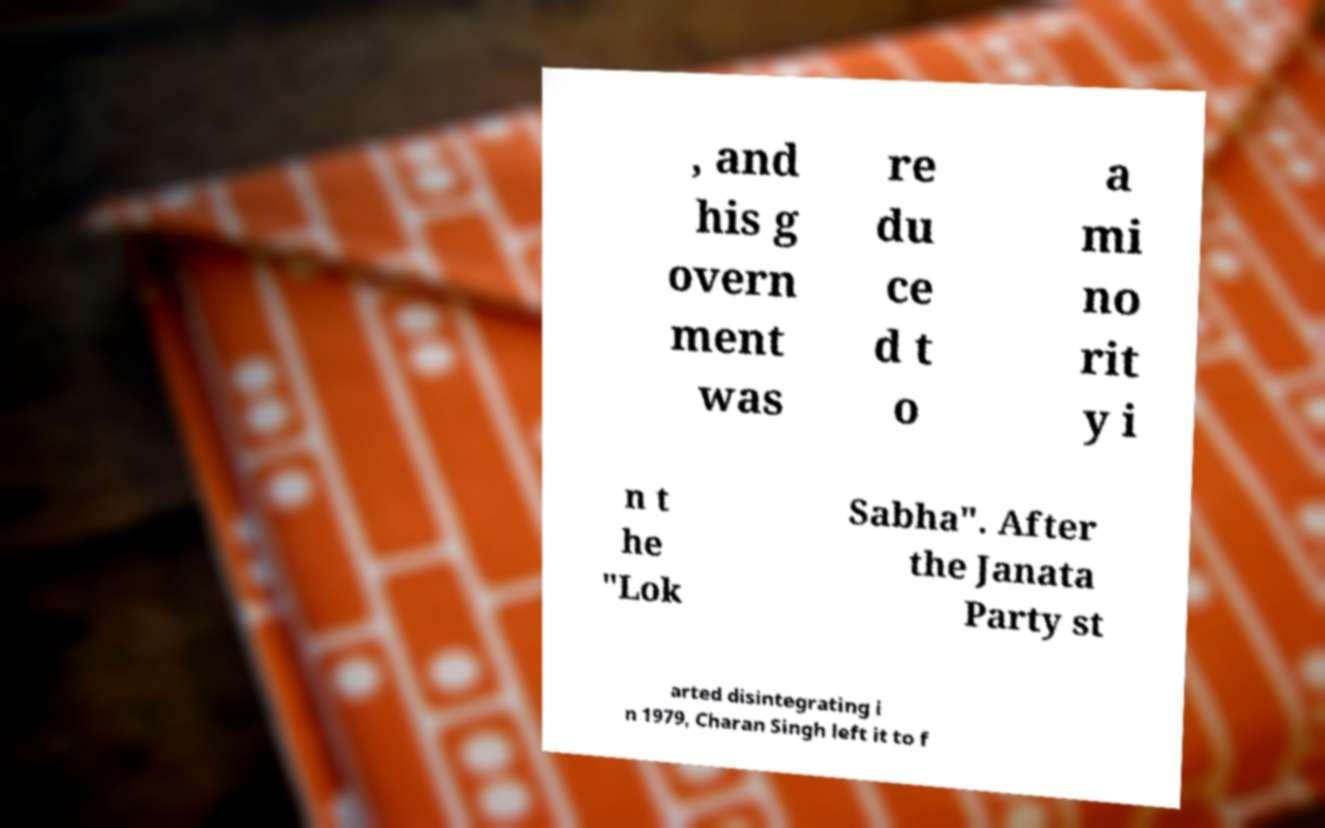Can you read and provide the text displayed in the image?This photo seems to have some interesting text. Can you extract and type it out for me? , and his g overn ment was re du ce d t o a mi no rit y i n t he "Lok Sabha". After the Janata Party st arted disintegrating i n 1979, Charan Singh left it to f 